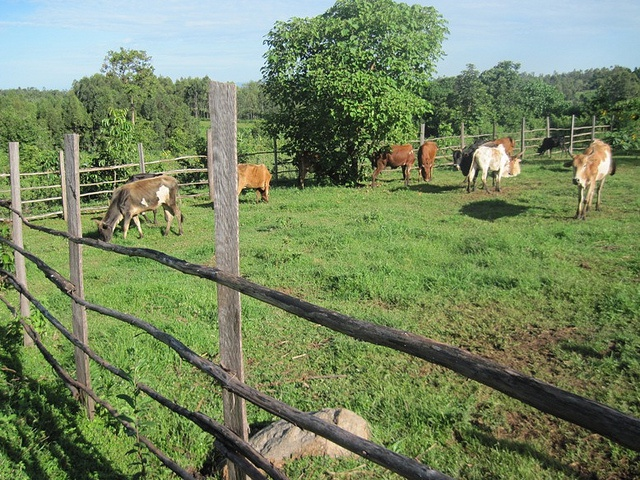Describe the objects in this image and their specific colors. I can see cow in lightblue, tan, gray, and darkgreen tones, cow in lightblue and tan tones, cow in lightblue, ivory, tan, and gray tones, cow in lightblue, tan, and black tones, and cow in lightblue, gray, maroon, black, and brown tones in this image. 